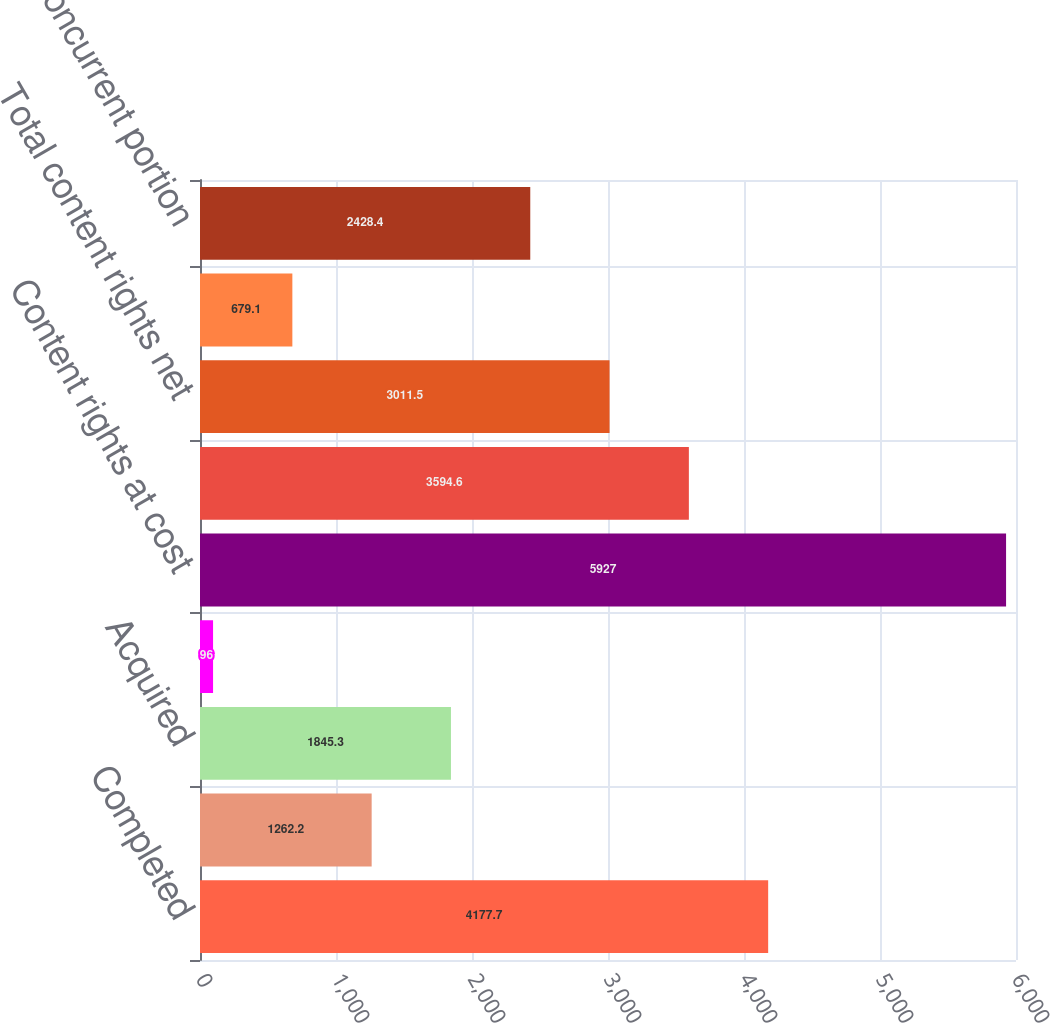Convert chart. <chart><loc_0><loc_0><loc_500><loc_500><bar_chart><fcel>Completed<fcel>In-production<fcel>Acquired<fcel>Prepaid<fcel>Content rights at cost<fcel>Accumulated amortization<fcel>Total content rights net<fcel>Current portion<fcel>Noncurrent portion<nl><fcel>4177.7<fcel>1262.2<fcel>1845.3<fcel>96<fcel>5927<fcel>3594.6<fcel>3011.5<fcel>679.1<fcel>2428.4<nl></chart> 